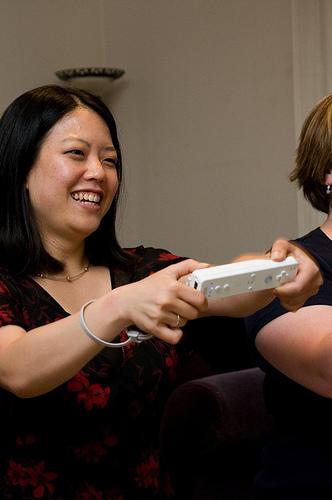Is the woman playing a game?
Answer briefly. Yes. What device is the woman holding in her hand?
Give a very brief answer. Wii remote. Does the woman look like she is having fun?
Give a very brief answer. Yes. 